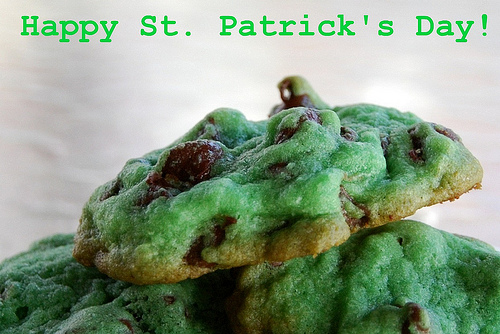<image>
Can you confirm if the words is above the chocolate chip? Yes. The words is positioned above the chocolate chip in the vertical space, higher up in the scene. 